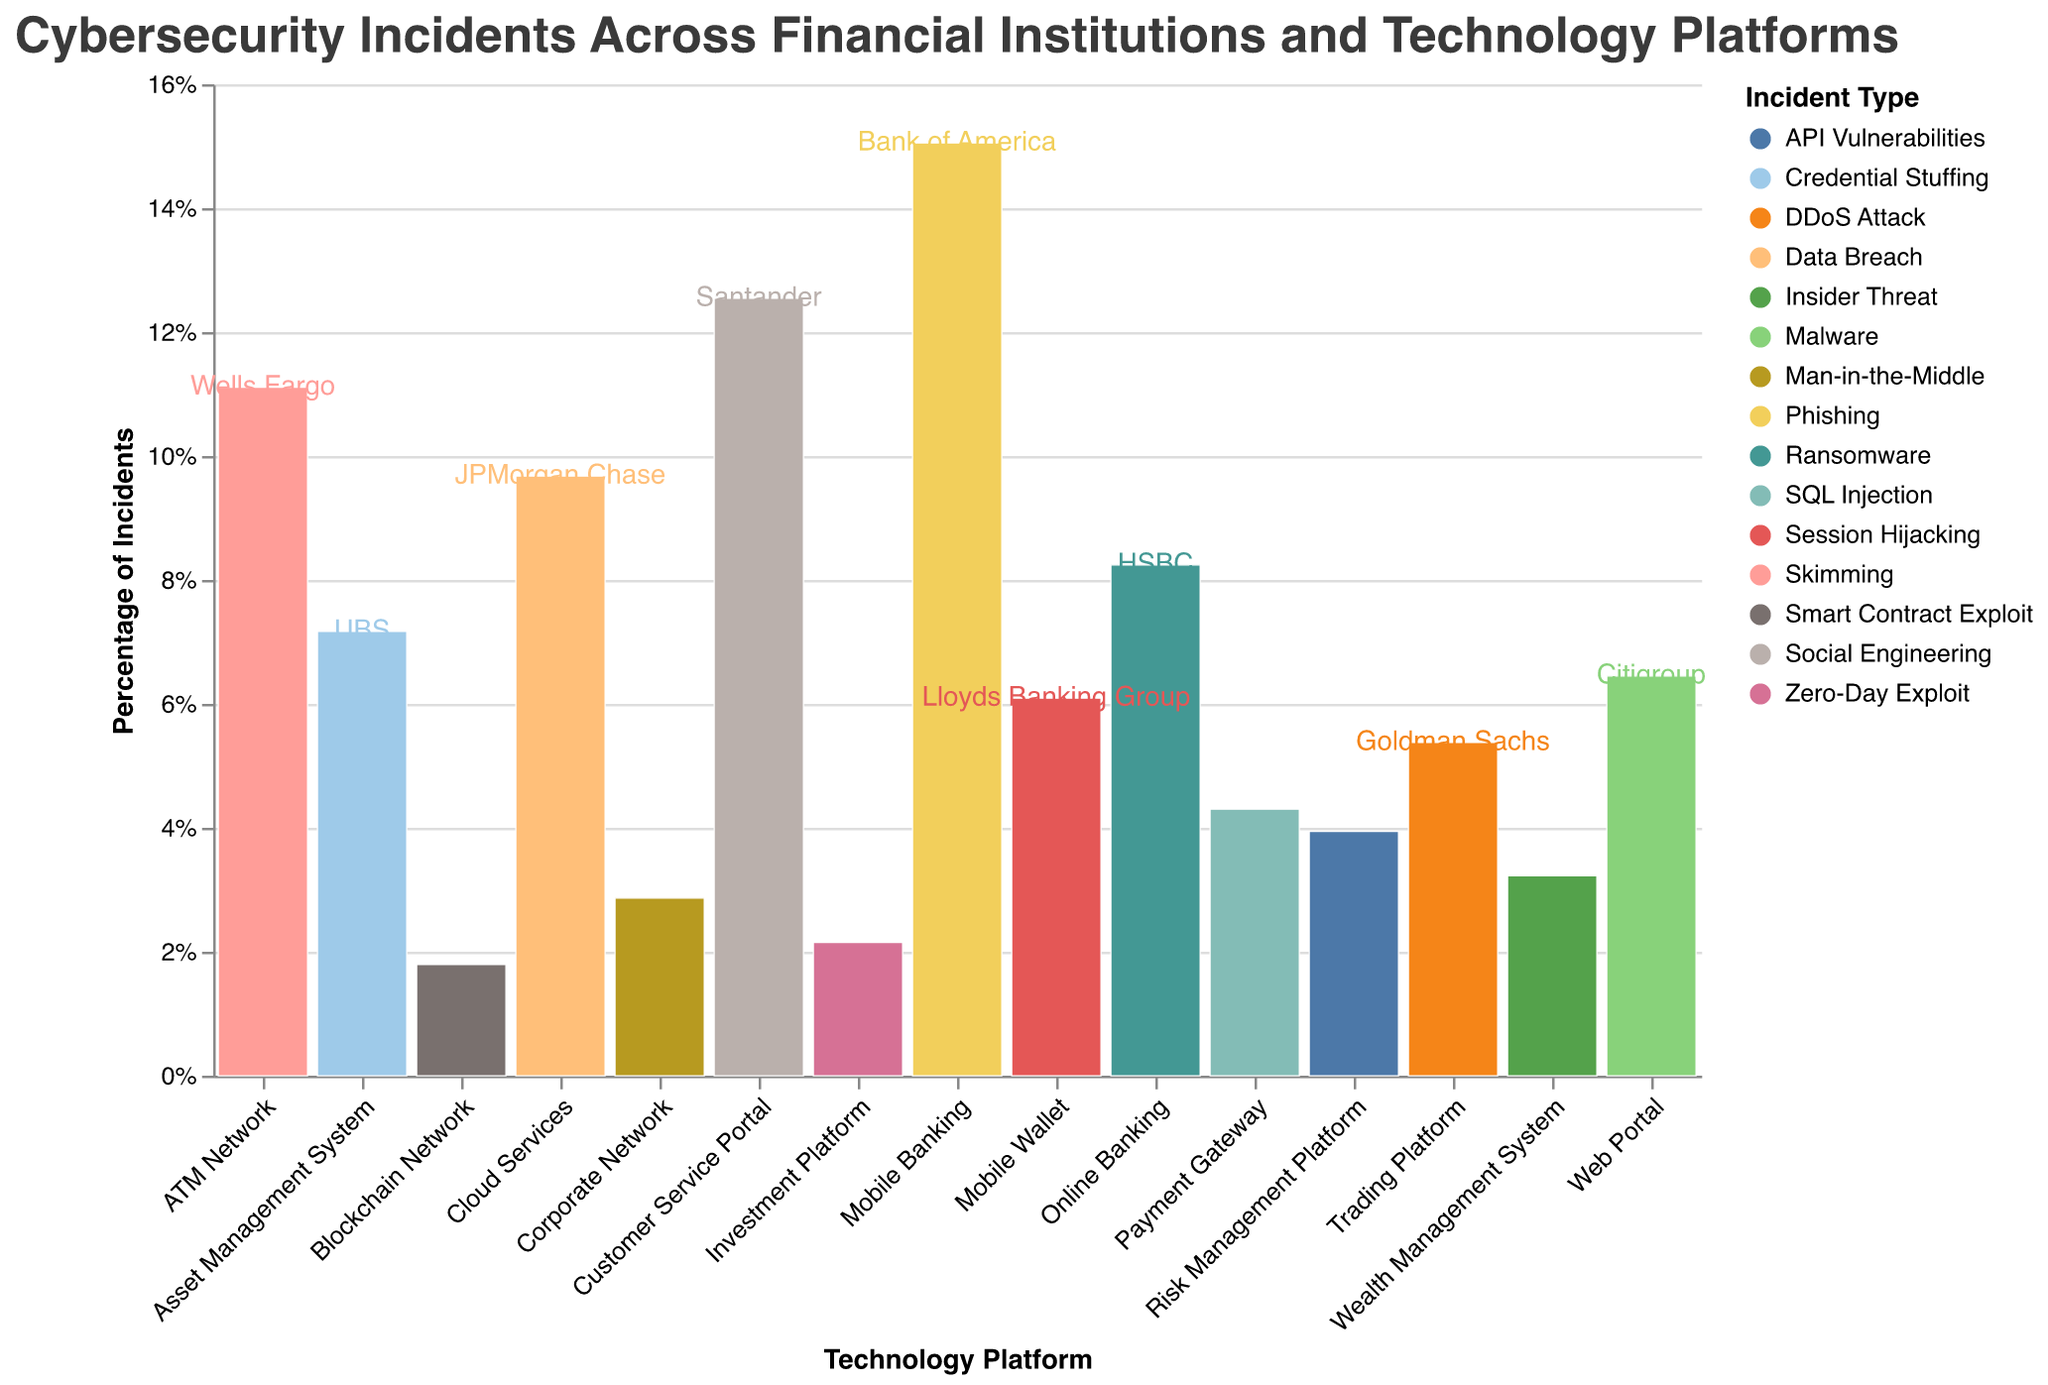How many types of cybersecurity incidents are displayed in the figure? The legend on the right side of the figure lists the different types of cybersecurity incidents depicted in various colors. By counting the distinct entries, we determine the number of incident types.
Answer: 15 Which financial institution has the highest frequency of phishing incidents? Look for the "Phishing" incident type in the legend and trace its corresponding color on the x-axis marked by financial institutions. The bar representing Bank of America (Mobile Banking) has the highest value for "Phishing" incidents.
Answer: Bank of America What technology platform has the highest incident percentage for skimming attacks? Identify the "Skimming" incident type in the legend and match its color with bars in the figure. Track where this color has the highest vertical portion among different platforms. The "ATM Network" associated with Wells Fargo shows the highest percentage.
Answer: ATM Network Compare the frequency of DDoS attacks and Social Engineering incidents. Which one is more frequent? Refer to the legend colors for "DDoS Attack" and "Social Engineering". match these colors with the bars in the figure. By visually assessing the height, "Social Engineering" incidents related to Santander's Customer Service Portal are more frequent than "DDoS Attack" incidents associated with Goldman Sachs' Trading Platform.
Answer: Social Engineering What's the cumulative frequency of ransomware attacks across all institutions? Locate the "Ransomware" incident type in the legend and sum the frequency by observing the heights for HSBC represented by color code.
Answer: 23 What financial institution is associated with the highest percentage of cybersecurity incidents on cloud services? Check the "Cloud Services" section on the x-axis and identify the financial institution label that is included in the figure by a specific placement of percentage height in this section. "JPMorgan Chase" having data breaches at 27 incidents thus shows the highest involvement.
Answer: JPMorgan Chase Which financial institution experiences incidents related to blockchain networks? Trace the "Blockchain Network" along the "Platform" axis. Look for the corresponding bar and label for "Blockchain Network". The associated incidents belong to "ING Group".
Answer: ING Group Compare the percentage of malware incidents on web portals with session hijacking on mobile wallets. Which has a higher percentage? Identify and compare the colored bars for "Malware" under "Web Portals" and "Session Hijacking" under "Mobile Wallet" appearing along the respective platforms. “Session Hijacking” has a visually less portion compared with the “Malware” bar.
Answer: Malware What technology platform has the most varied incident types? Evaluate the width of different sections on the x-axis marked platforms. Count the distinct colors (incident types) within each section. "Mobile Banking" and "Customer Service Portal" seem to have a higher variety since visual scatter and labels seem largest.
Answer: Mobile Banking 